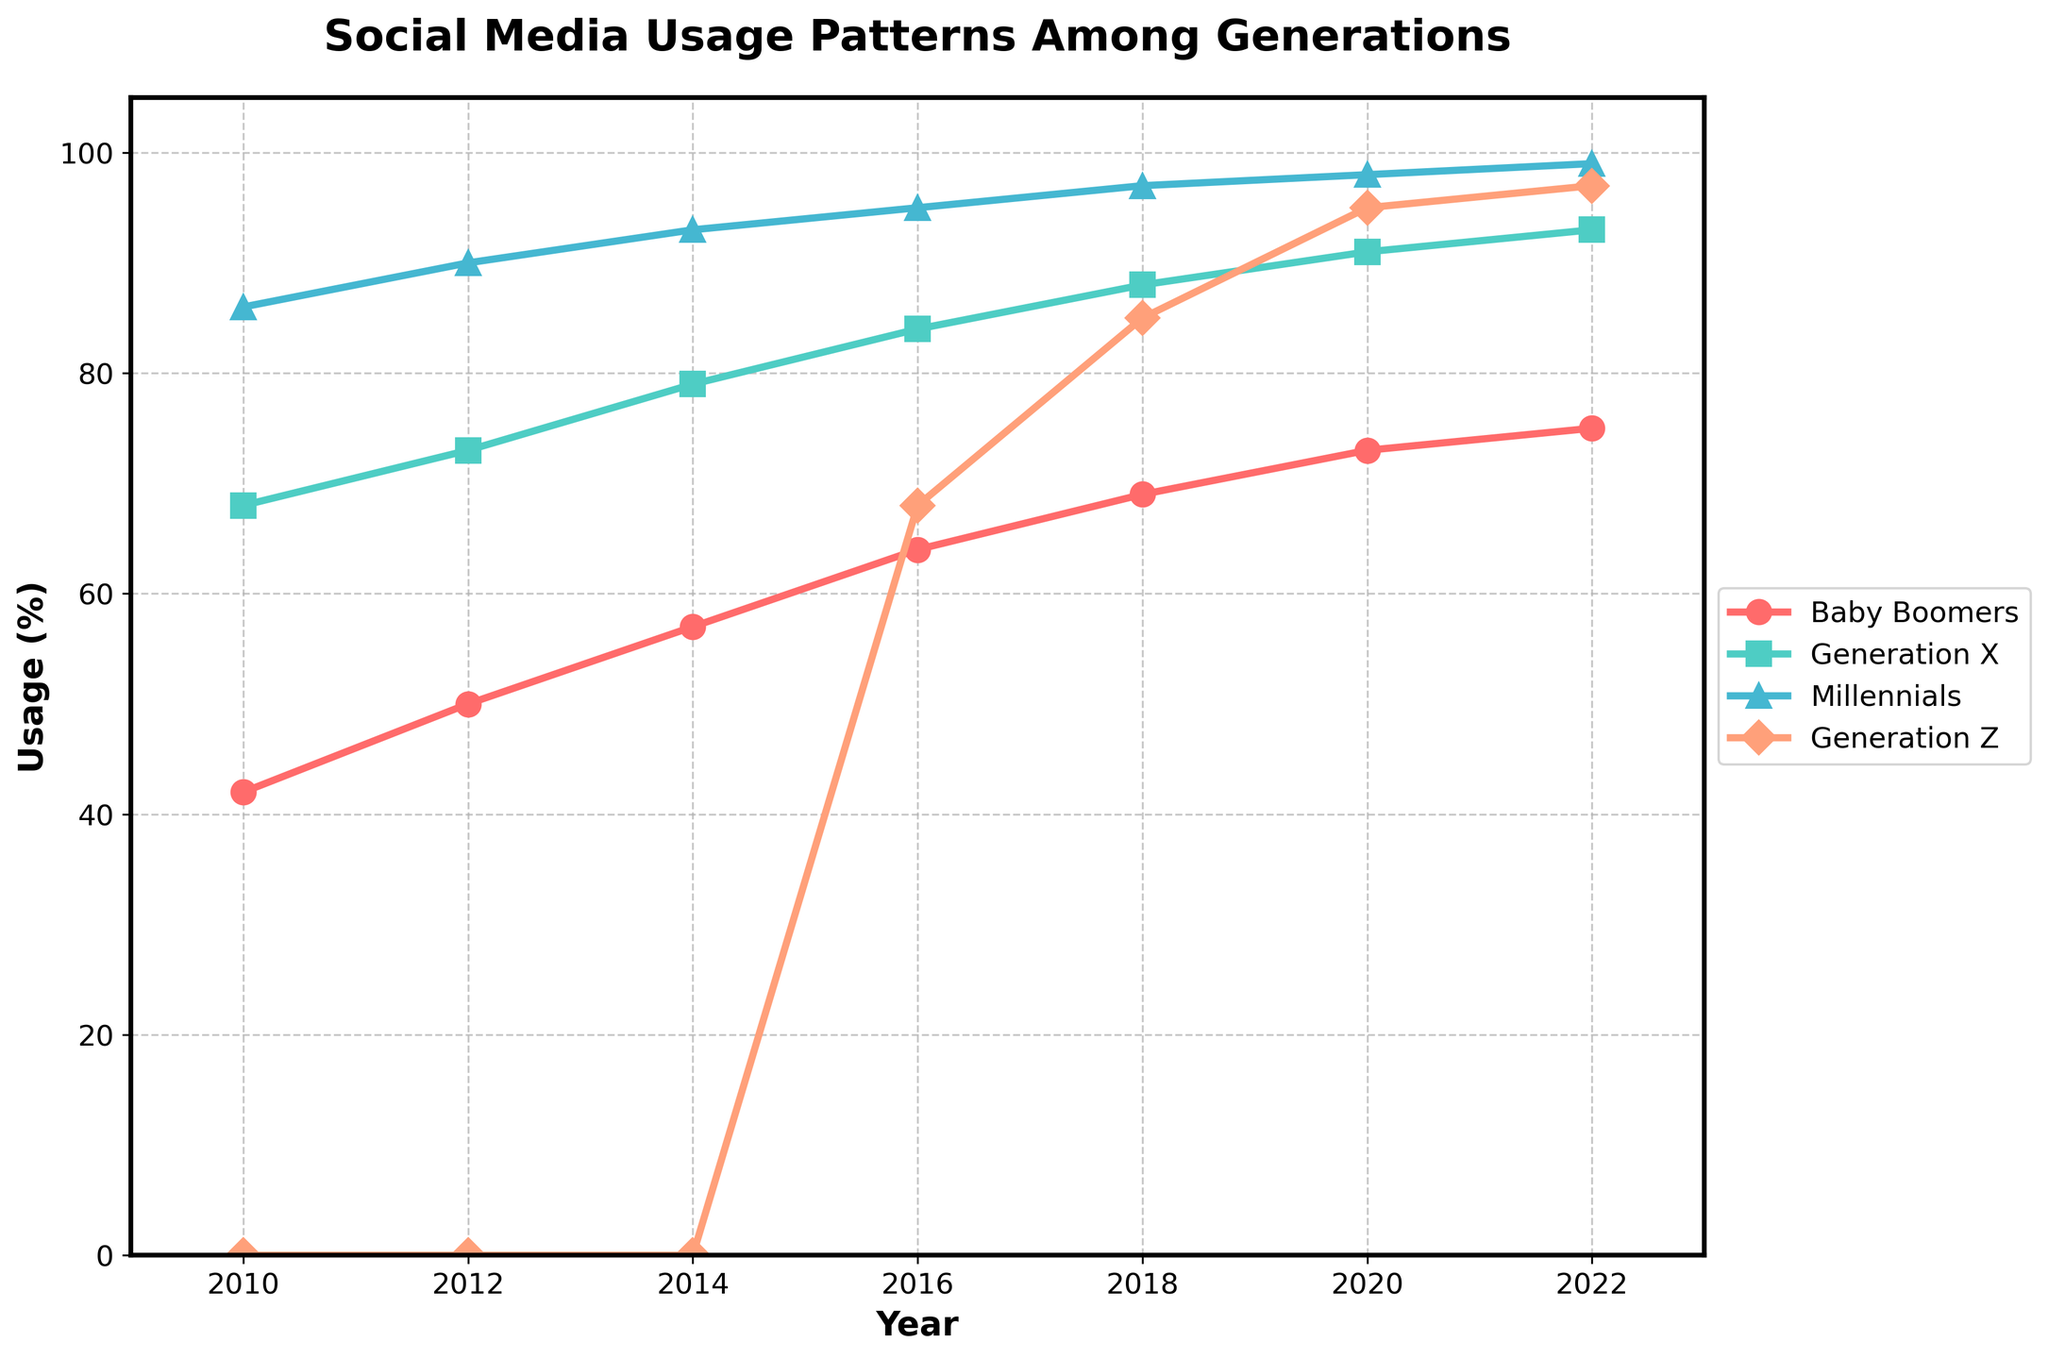What generation had the highest increase in social media usage from 2010 to 2022? First, find the usage values for each generation in 2010 and 2022. Calculate the increase for each: Baby Boomers (75-42), Generation X (93-68), Millennials (99-86), and Generation Z (97-0). The increase values are 33, 25, 13, and 97 respectively. Generation Z shows the highest increase.
Answer: Generation Z Which generation had the highest social media usage in 2016? Refer to the 2016 data points: Baby Boomers (64), Generation X (84), Millennials (95), and Generation Z (68). Among all, Millennials have the highest value of 95.
Answer: Millennials What was the average social media usage for Millennials from 2010 to 2022? Add up all the values for Millennials from 2010 to 2022: (86 + 90 + 93 + 95 + 97 + 98 + 99) = 658. Divide by the number of values, which is 7. The average is 658 / 7 ≈ 94.
Answer: 94 Is there any year where Generation Z's usage exceeded that of Baby Boomers? If yes, which year(s)? Compare the values year by year. In 2016 (68), 2018 (85), 2020 (95), and 2022 (97), Generation Z's usage exceeded Baby Boomers’ values (64, 69, 73, 75). So, the years are 2016, 2018, 2020, and 2022.
Answer: 2016, 2018, 2020, 2022 Between which consecutive years did Baby Boomers experience the highest increase in social media usage? Calculate the yearly increases: 2010-2012 (50-42=8), 2012-2014 (57-50=7), 2014-2016 (64-57=7), 2016-2018 (69-64=5), 2018-2020 (73-69=4), 2020-2022 (75-73=2). The highest increase is 8 between 2010 and 2012.
Answer: 2010-2012 In 2018, what is the difference in the social media usage between the oldest and youngest generations? Find the values for 2018: Baby Boomers (69) and Generation Z (85). The difference is 85 - 69 = 16.
Answer: 16 What color represents the Millennials in the chart? Based on visual observation, the data suggests Millennials are represented by the blue line.
Answer: Blue What is the trend in social media usage for Generation X from 2010 to 2022? Observe the line representing Generation X through the years 2010-2022: It starts at 68 and gradually increases to 93, indicating an upward trend.
Answer: Upward trend By how much did social media usage for Baby Boomers increase from 2012 to 2014? Find the values for these years: 2012 (50) and 2014 (57). The increase is 57 - 50 = 7.
Answer: 7 